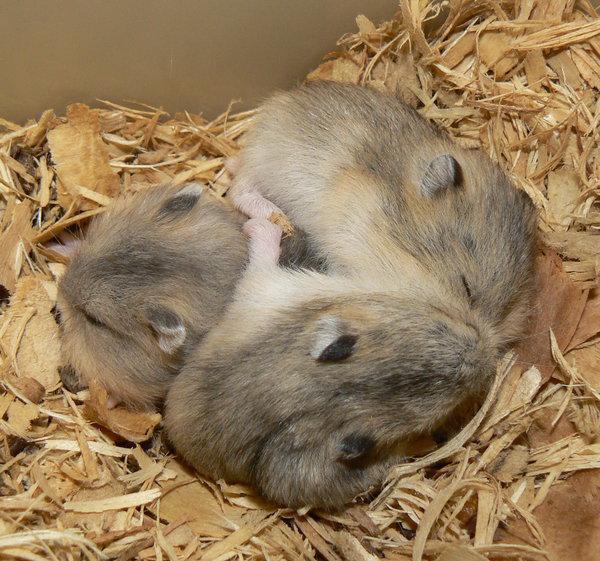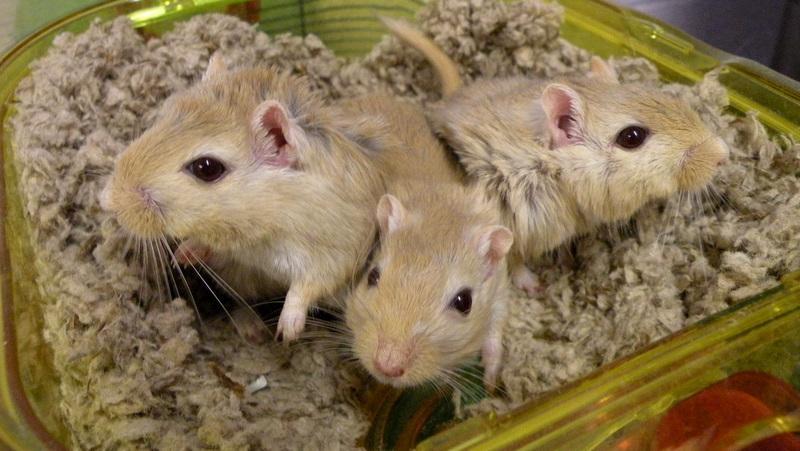The first image is the image on the left, the second image is the image on the right. For the images displayed, is the sentence "In one of the images, at least one rodent is being held by a human hand." factually correct? Answer yes or no. No. The first image is the image on the left, the second image is the image on the right. Evaluate the accuracy of this statement regarding the images: "At least one of the rodents is resting in a human hand.". Is it true? Answer yes or no. No. 